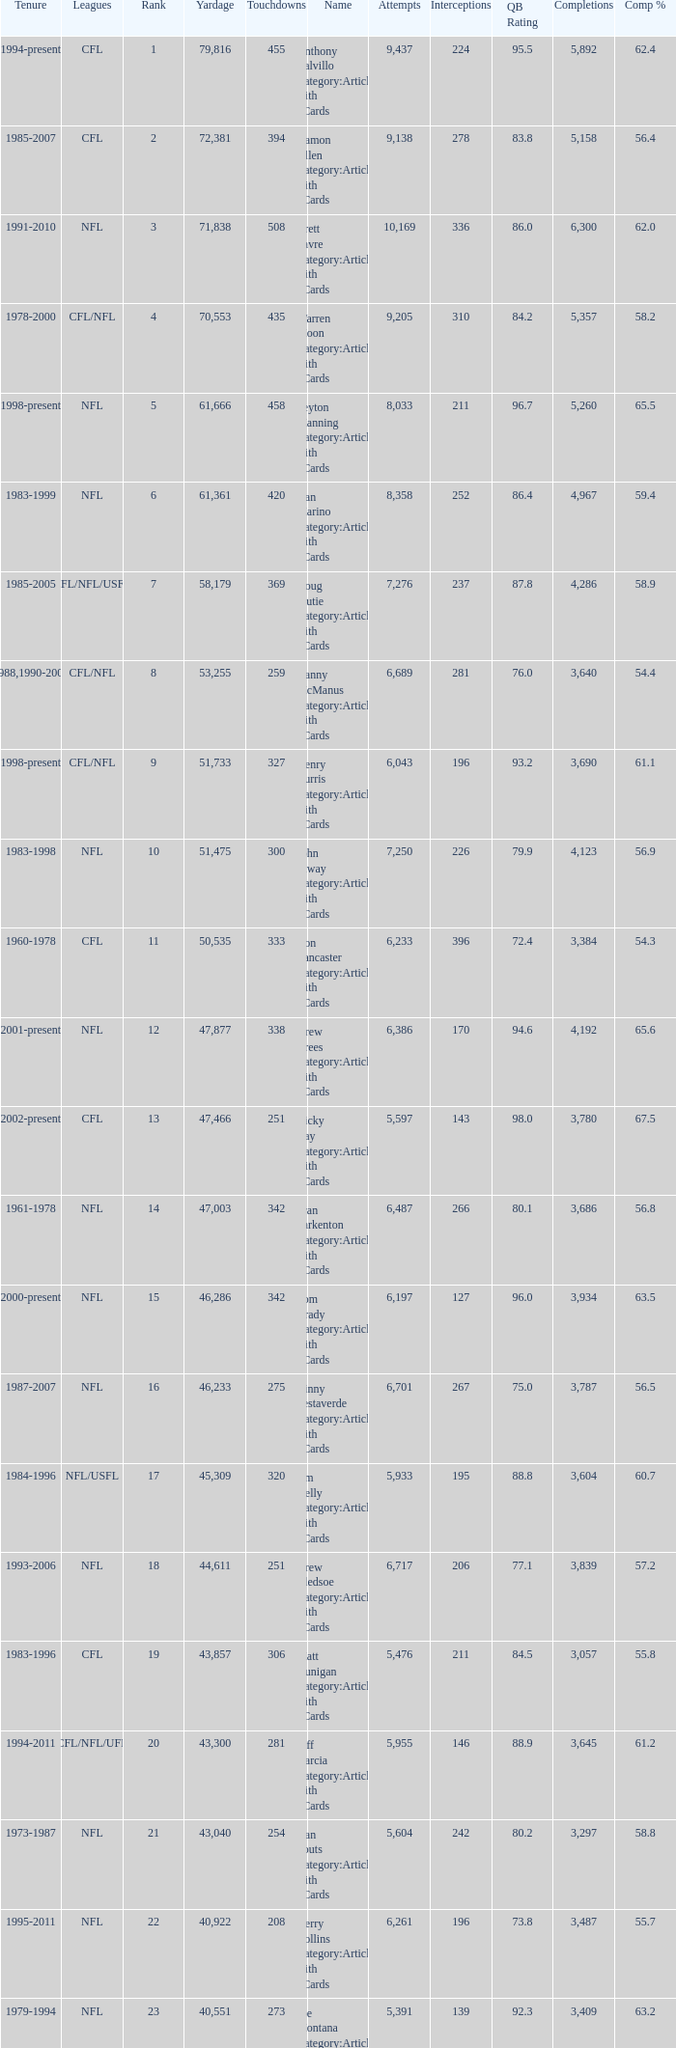What is the number of interceptions with less than 3,487 completions , more than 40,551 yardage, and the comp % is 55.8? 211.0. 